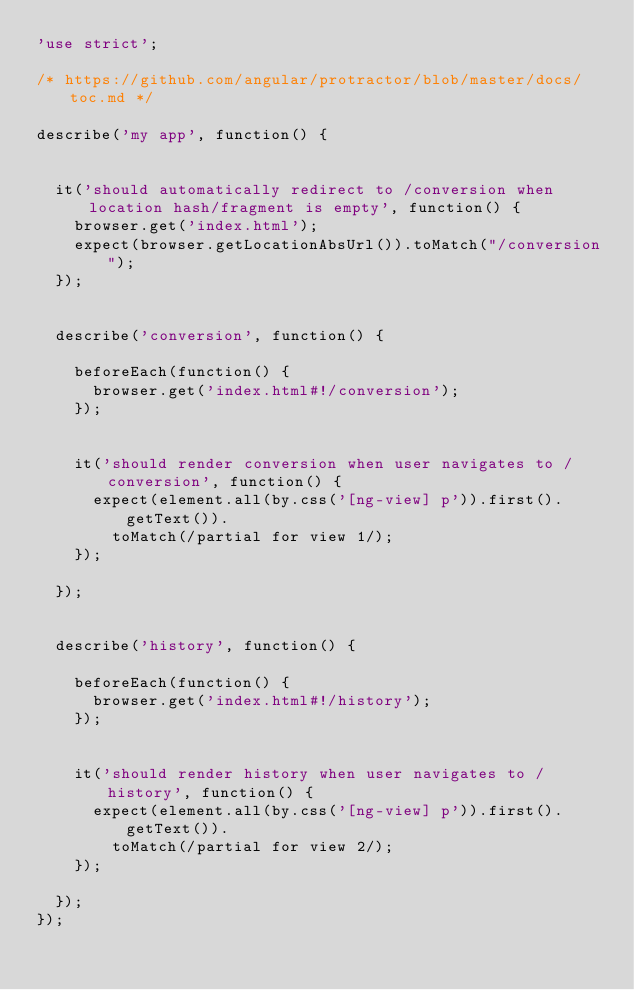<code> <loc_0><loc_0><loc_500><loc_500><_JavaScript_>'use strict';

/* https://github.com/angular/protractor/blob/master/docs/toc.md */

describe('my app', function() {


  it('should automatically redirect to /conversion when location hash/fragment is empty', function() {
    browser.get('index.html');
    expect(browser.getLocationAbsUrl()).toMatch("/conversion");
  });


  describe('conversion', function() {

    beforeEach(function() {
      browser.get('index.html#!/conversion');
    });


    it('should render conversion when user navigates to /conversion', function() {
      expect(element.all(by.css('[ng-view] p')).first().getText()).
        toMatch(/partial for view 1/);
    });

  });


  describe('history', function() {

    beforeEach(function() {
      browser.get('index.html#!/history');
    });


    it('should render history when user navigates to /history', function() {
      expect(element.all(by.css('[ng-view] p')).first().getText()).
        toMatch(/partial for view 2/);
    });

  });
});
</code> 